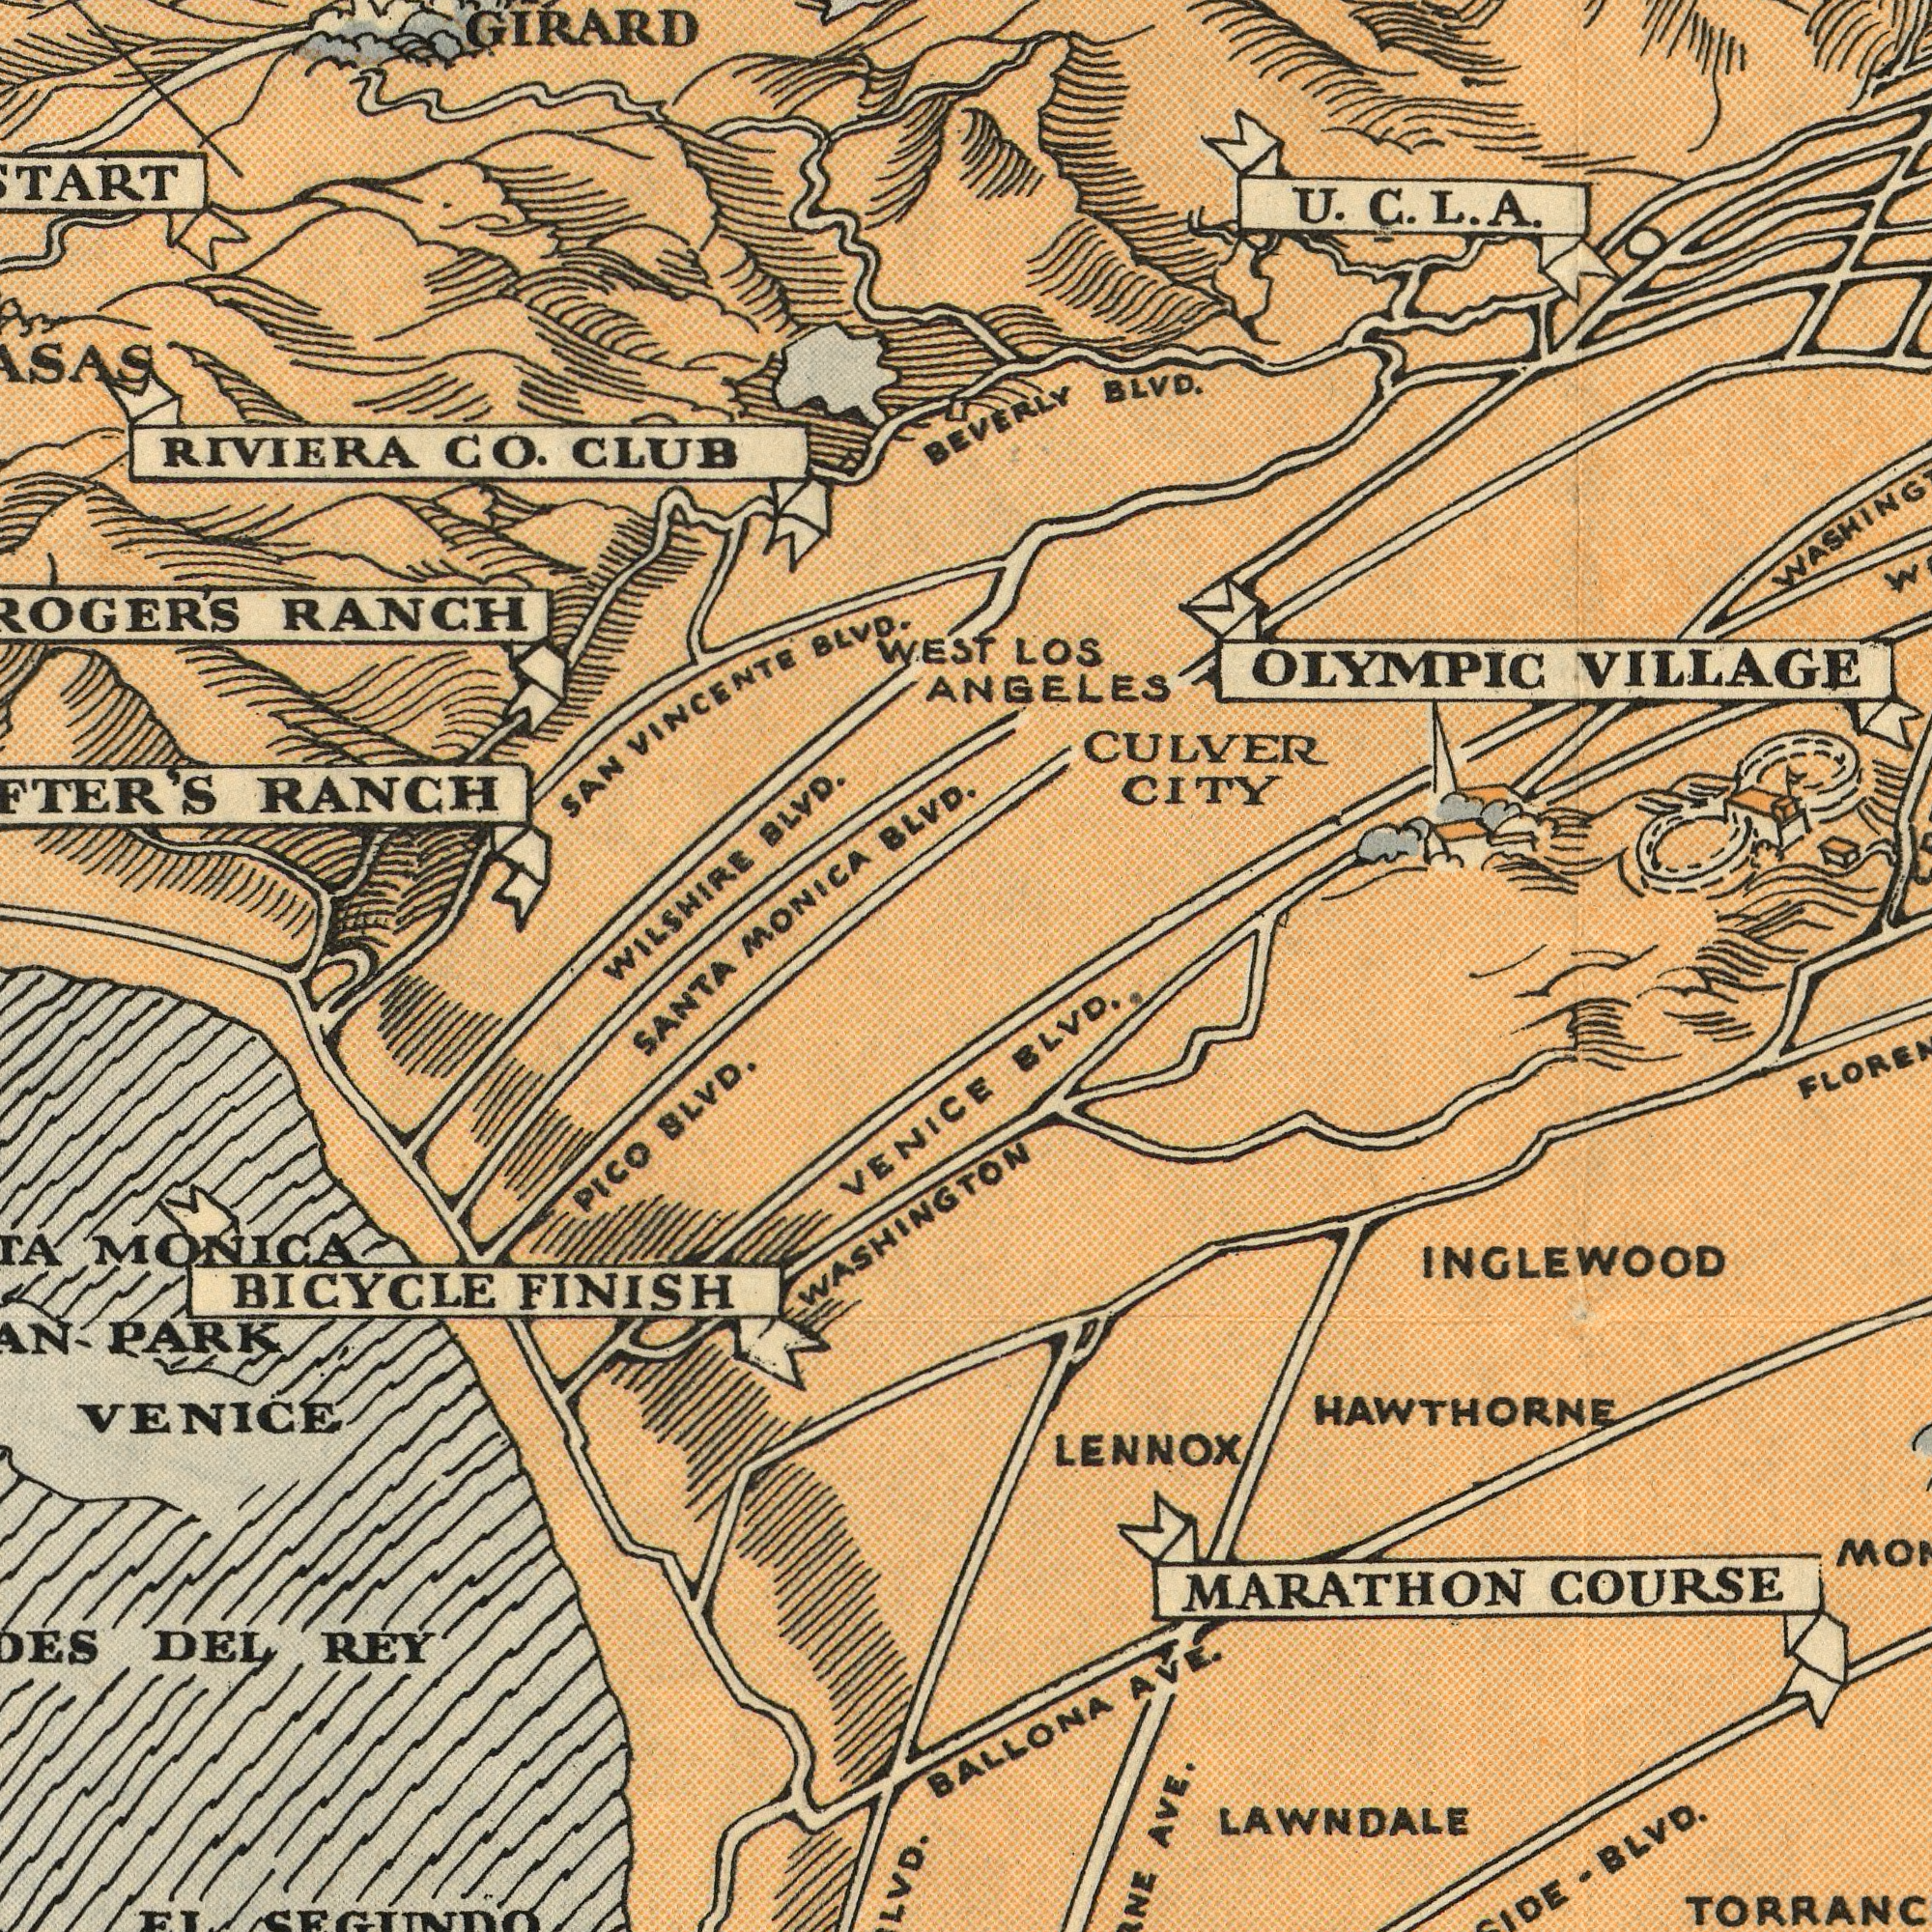What text appears in the bottom-right area of the image? BLVD MARATHON COURSE LENNOX AVE. BALLONA AVE. INGLEWOOD LAWNDALE - BLVD. HAWTHORNE What text is shown in the bottom-left quadrant? SANTA WASHINGTON PARK DEL REY VENICE BICYCLE FINISH VENICE PICO BLVD. MONICA SEGUNDO What text can you see in the top-left section? RANCH MONICA BLVD SAN VINCENTE BLVD. RIVIERA CO. CLUB VILSHIRE BLVD. RANCH WEST GIRARD What text is visible in the upper-right corner? LOS ANGELES CULVER CITY U. C. L. A. OLYMPIC VILLAGE BEVERLY BLVD. 